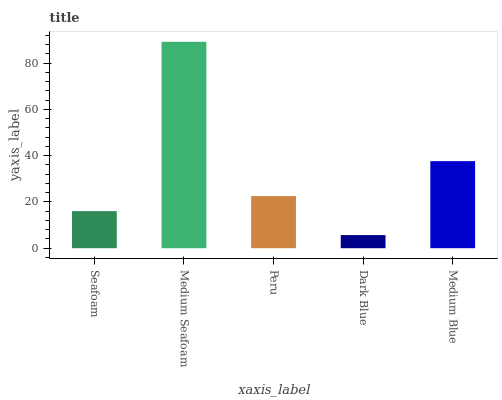Is Dark Blue the minimum?
Answer yes or no. Yes. Is Medium Seafoam the maximum?
Answer yes or no. Yes. Is Peru the minimum?
Answer yes or no. No. Is Peru the maximum?
Answer yes or no. No. Is Medium Seafoam greater than Peru?
Answer yes or no. Yes. Is Peru less than Medium Seafoam?
Answer yes or no. Yes. Is Peru greater than Medium Seafoam?
Answer yes or no. No. Is Medium Seafoam less than Peru?
Answer yes or no. No. Is Peru the high median?
Answer yes or no. Yes. Is Peru the low median?
Answer yes or no. Yes. Is Seafoam the high median?
Answer yes or no. No. Is Seafoam the low median?
Answer yes or no. No. 